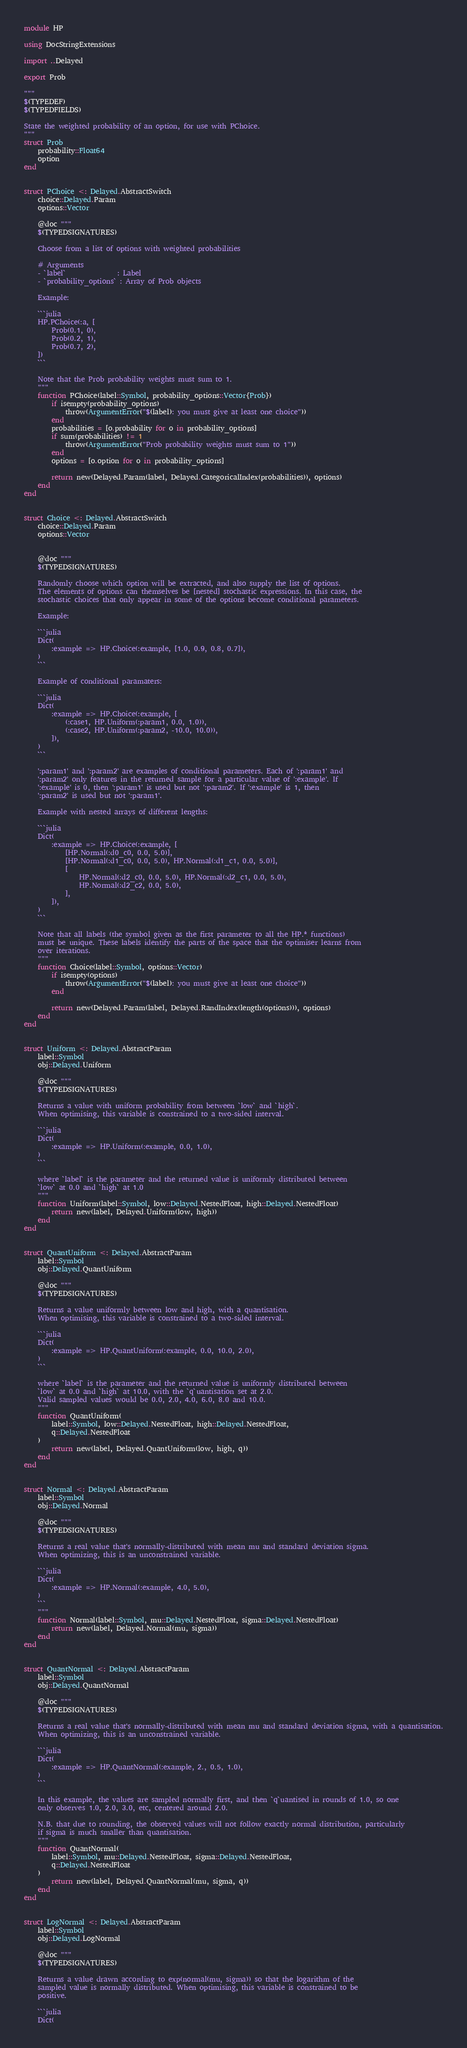<code> <loc_0><loc_0><loc_500><loc_500><_Julia_>module HP

using DocStringExtensions

import ..Delayed

export Prob

"""
$(TYPEDEF)
$(TYPEDFIELDS)

State the weighted probability of an option, for use with PChoice.
"""
struct Prob
    probability::Float64
    option
end


struct PChoice <: Delayed.AbstractSwitch
    choice::Delayed.Param
    options::Vector

    @doc """
    $(TYPEDSIGNATURES)

    Choose from a list of options with weighted probabilities

    # Arguments
    - `label`               : Label
    - `probability_options` : Array of Prob objects

    Example:

    ```julia
    HP.PChoice(:a, [
        Prob(0.1, 0),
        Prob(0.2, 1),
        Prob(0.7, 2),
    ])
    ```

    Note that the Prob probability weights must sum to 1.
    """
    function PChoice(label::Symbol, probability_options::Vector{Prob})
        if isempty(probability_options)
            throw(ArgumentError("$(label): you must give at least one choice"))
        end
        probabilities = [o.probability for o in probability_options]
        if sum(probabilities) != 1
            throw(ArgumentError("Prob probability weights must sum to 1"))
        end
        options = [o.option for o in probability_options]

        return new(Delayed.Param(label, Delayed.CategoricalIndex(probabilities)), options)
    end
end


struct Choice <: Delayed.AbstractSwitch
    choice::Delayed.Param
    options::Vector


    @doc """
    $(TYPEDSIGNATURES)

    Randomly choose which option will be extracted, and also supply the list of options.
    The elements of options can themselves be [nested] stochastic expressions. In this case, the
    stochastic choices that only appear in some of the options become conditional parameters.

    Example:

    ```julia
    Dict(
        :example => HP.Choice(:example, [1.0, 0.9, 0.8, 0.7]),
    )
    ```

    Example of conditional paramaters:

    ```julia
    Dict(
        :example => HP.Choice(:example, [
            (:case1, HP.Uniform(:param1, 0.0, 1.0)),
            (:case2, HP.Uniform(:param2, -10.0, 10.0)),
        ]),
    )
    ```

    ':param1' and ':param2' are examples of conditional parameters. Each of ':param1' and
    ':param2' only features in the returned sample for a particular value of ':example'. If
    ':example' is 0, then ':param1' is used but not ':param2'. If ':example' is 1, then
    ':param2' is used but not ':param1'.

    Example with nested arrays of different lengths:

    ```julia
    Dict(
        :example => HP.Choice(:example, [
            [HP.Normal(:d0_c0, 0.0, 5.0)],
            [HP.Normal(:d1_c0, 0.0, 5.0), HP.Normal(:d1_c1, 0.0, 5.0)],
            [
                HP.Normal(:d2_c0, 0.0, 5.0), HP.Normal(:d2_c1, 0.0, 5.0),
                HP.Normal(:d2_c2, 0.0, 5.0),
            ],
        ]),
    )
    ```

    Note that all labels (the symbol given as the first parameter to all the HP.* functions)
    must be unique. These labels identify the parts of the space that the optimiser learns from
    over iterations.
    """
    function Choice(label::Symbol, options::Vector)
        if isempty(options)
            throw(ArgumentError("$(label): you must give at least one choice"))
        end

        return new(Delayed.Param(label, Delayed.RandIndex(length(options))), options)
    end
end


struct Uniform <: Delayed.AbstractParam
    label::Symbol
    obj::Delayed.Uniform

    @doc """
    $(TYPEDSIGNATURES)

    Returns a value with uniform probability from between `low` and `high`.
    When optimising, this variable is constrained to a two-sided interval.

    ```julia
    Dict(
        :example => HP.Uniform(:example, 0.0, 1.0),
    )
    ```

    where `label` is the parameter and the returned value is uniformly distributed between
    `low` at 0.0 and `high` at 1.0
    """
    function Uniform(label::Symbol, low::Delayed.NestedFloat, high::Delayed.NestedFloat)
        return new(label, Delayed.Uniform(low, high))
    end
end


struct QuantUniform <: Delayed.AbstractParam
    label::Symbol
    obj::Delayed.QuantUniform

    @doc """
    $(TYPEDSIGNATURES)

    Returns a value uniformly between low and high, with a quantisation.
    When optimising, this variable is constrained to a two-sided interval.

    ```julia
    Dict(
        :example => HP.QuantUniform(:example, 0.0, 10.0, 2.0),
    )
    ```

    where `label` is the parameter and the returned value is uniformly distributed between
    `low` at 0.0 and `high` at 10.0, with the `q`uantisation set at 2.0.
    Valid sampled values would be 0.0, 2.0, 4.0, 6.0, 8.0 and 10.0.
    """
    function QuantUniform(
        label::Symbol, low::Delayed.NestedFloat, high::Delayed.NestedFloat,
        q::Delayed.NestedFloat
    )
        return new(label, Delayed.QuantUniform(low, high, q))
    end
end


struct Normal <: Delayed.AbstractParam
    label::Symbol
    obj::Delayed.Normal

    @doc """
    $(TYPEDSIGNATURES)

    Returns a real value that's normally-distributed with mean mu and standard deviation sigma.
    When optimizing, this is an unconstrained variable.

    ```julia
    Dict(
        :example => HP.Normal(:example, 4.0, 5.0),
    )
    ```
    """
    function Normal(label::Symbol, mu::Delayed.NestedFloat, sigma::Delayed.NestedFloat)
        return new(label, Delayed.Normal(mu, sigma))
    end
end


struct QuantNormal <: Delayed.AbstractParam
    label::Symbol
    obj::Delayed.QuantNormal

    @doc """
    $(TYPEDSIGNATURES)

    Returns a real value that's normally-distributed with mean mu and standard deviation sigma, with a quantisation.
    When optimizing, this is an unconstrained variable.

    ```julia
    Dict(
        :example => HP.QuantNormal(:example, 2., 0.5, 1.0),
    )
    ```

    In this example, the values are sampled normally first, and then `q`uantised in rounds of 1.0, so one
    only observes 1.0, 2.0, 3.0, etc, centered around 2.0.

    N.B. that due to rounding, the observed values will not follow exactly normal distribution, particularly
    if sigma is much smaller than quantisation.
    """
    function QuantNormal(
        label::Symbol, mu::Delayed.NestedFloat, sigma::Delayed.NestedFloat,
        q::Delayed.NestedFloat
    )
        return new(label, Delayed.QuantNormal(mu, sigma, q))
    end
end


struct LogNormal <: Delayed.AbstractParam
    label::Symbol
    obj::Delayed.LogNormal

    @doc """
    $(TYPEDSIGNATURES)

    Returns a value drawn according to exp(normal(mu, sigma)) so that the logarithm of the
    sampled value is normally distributed. When optimising, this variable is constrained to be
    positive.

    ```julia
    Dict(</code> 